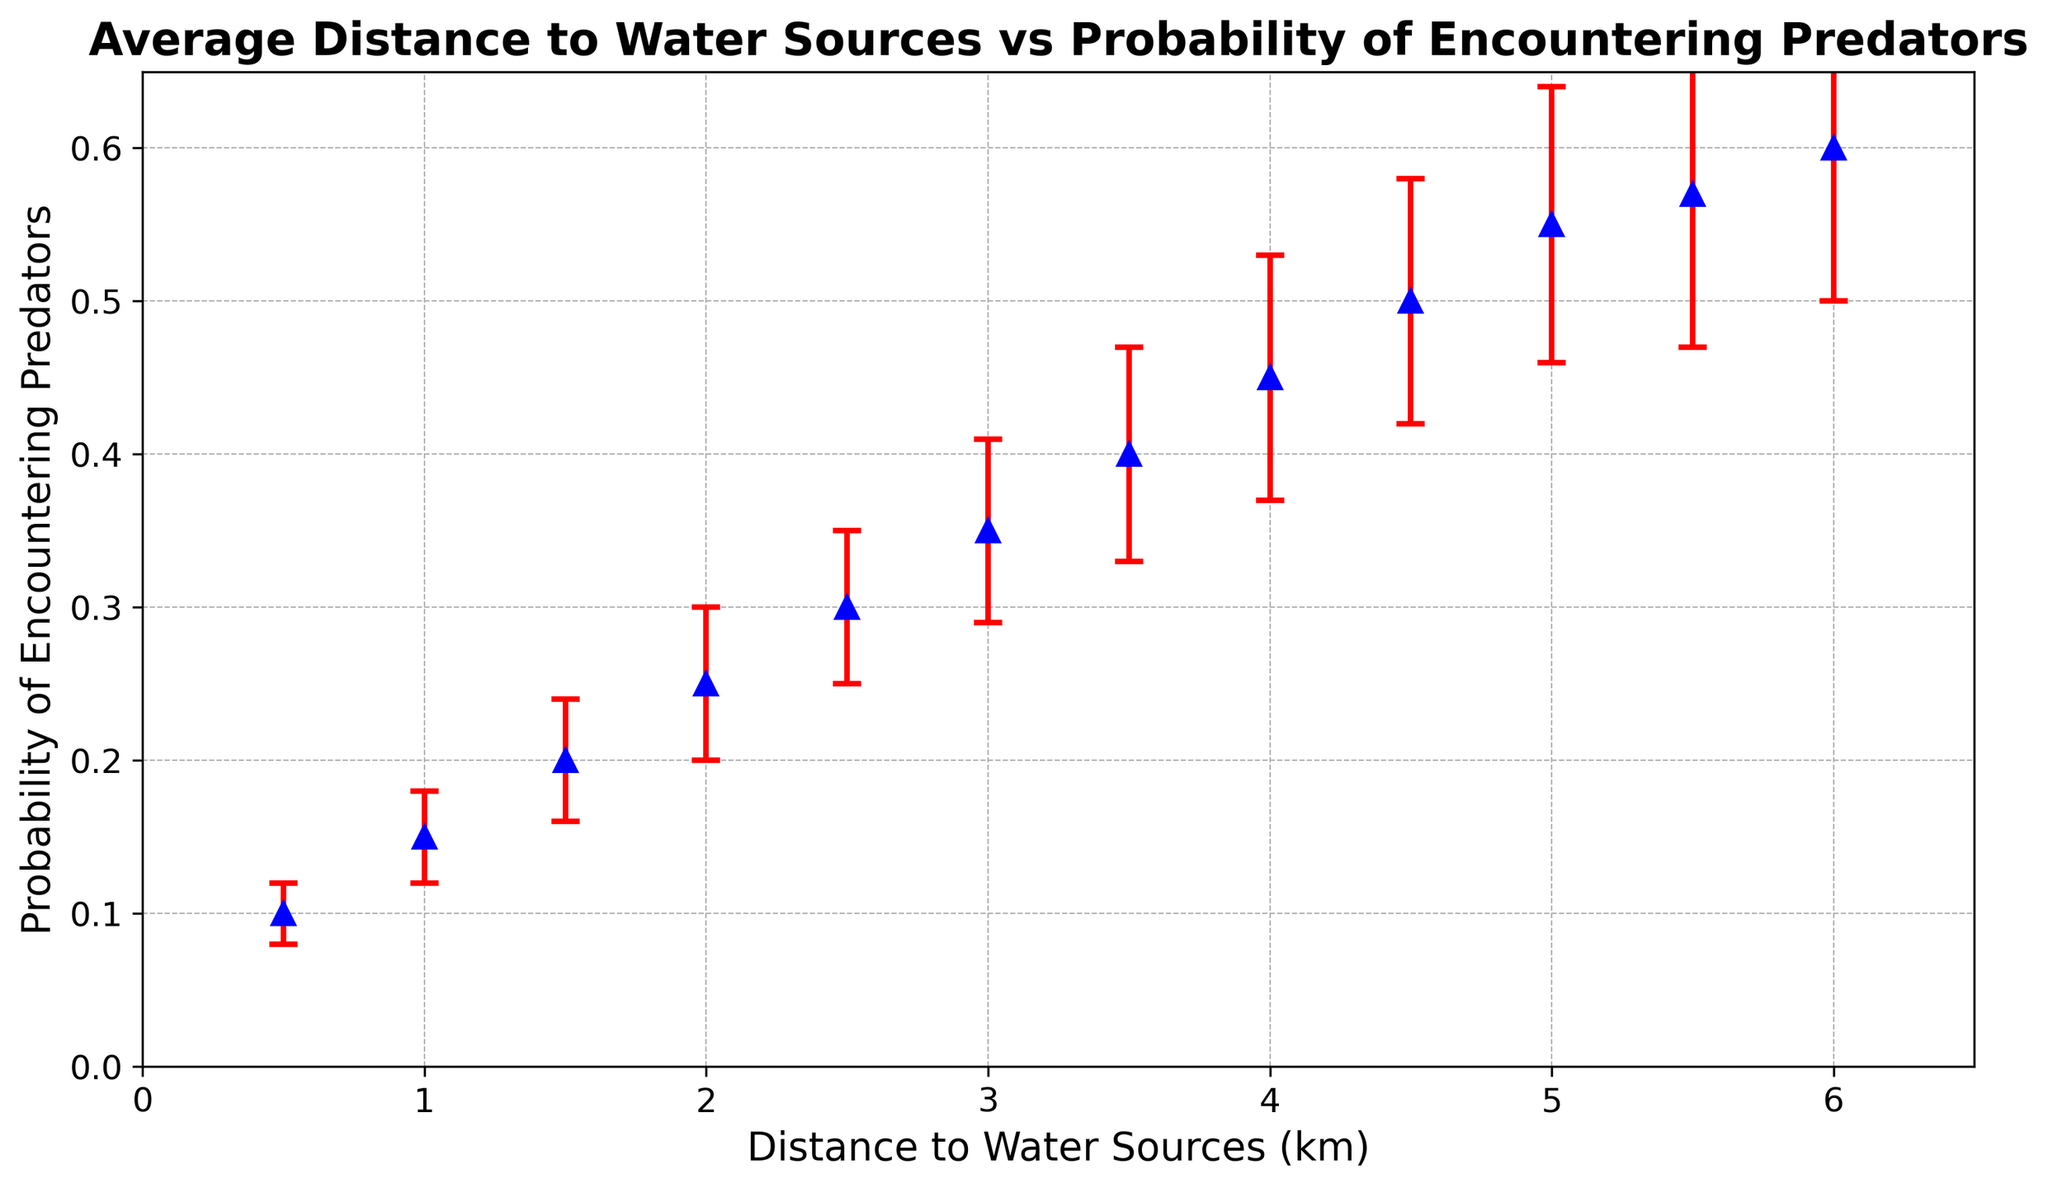What is the probability of encountering predators at a distance of 3 km from water sources? Locate the point on the plot where the distance is 3 km and read the corresponding probability value.
Answer: 0.35 Which distance to water sources corresponds to the highest probability of encountering predators according to the plot? Look for the data point with the highest y-value (probability) and note the corresponding x-value (distance).
Answer: 6 km How does the probability of encountering predators change as the distance to water sources increases from 0.5 km to 5 km? Observe the trend in the plot from 0.5 km to 5 km; the probability increases consistently.
Answer: Increases By how much does the probability of encountering predators increase when moving from 2 km to 5 km away from water sources? Find the probabilities at 2 km and 5 km and calculate the difference: 0.55 - 0.25.
Answer: 0.3 What is the general trend illustrated by the error bars as the distance to water sources increases? Observe the length of the error bars at increasing distances; they tend to get longer.
Answer: Error increases Compare the probability of encountering predators at 1 km and 4 km from water sources. Locate the probabilities at 1 km and 4 km and compare the values: 0.15 at 1 km and 0.45 at 4 km.
Answer: Higher at 4 km What is the probability of encountering predators at a distance of 0.5 km? Does it have a significant error? Read the probability value and the length of the error bar at 0.5 km. The probability is 0.1 with an error of 0.02, which is relatively small.
Answer: 0.1, no significant error How much error is associated with the probability of encountering predators at 3.5 km? Read the error value given for the 3.5 km distance point; it is 0.07.
Answer: 0.07 At what distance between 0.5 km and 6 km is the probability of encountering predators exactly 0.5? Identify the point on the plot where the probability is 0.5 and note the corresponding distance.
Answer: 4.5 km What visual changes occur in the marker style as you look at different distances in the plot? Observe the color (blue), shape (triangle), and size of the markers; they remain consistent across the plot.
Answer: Consistent 